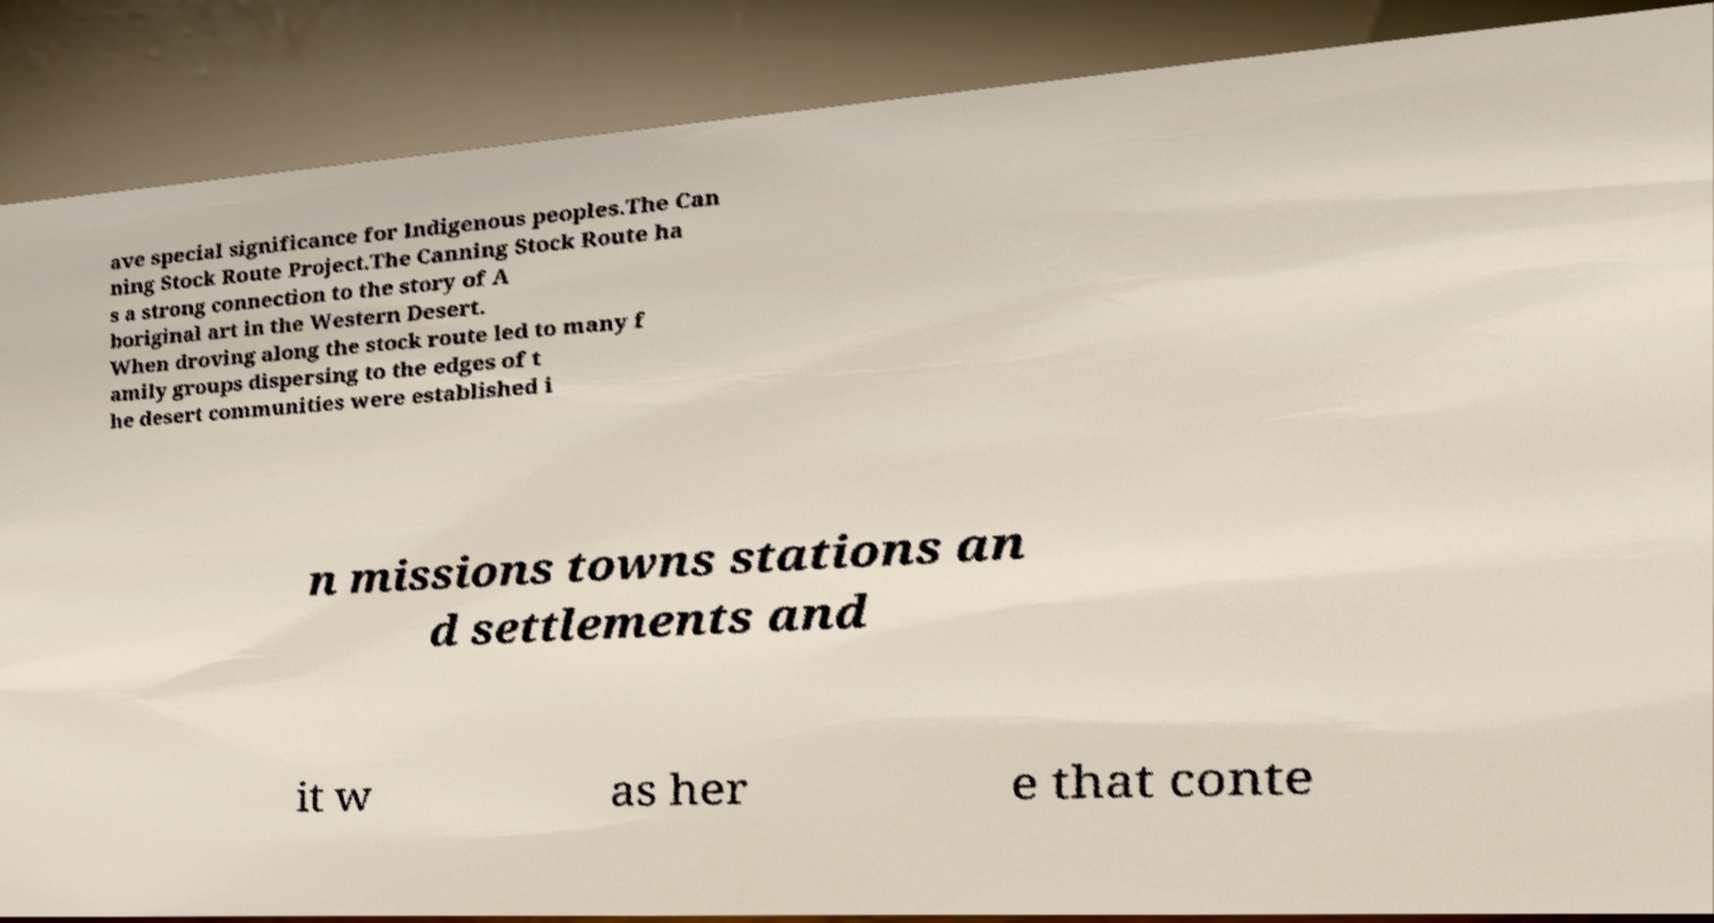Can you read and provide the text displayed in the image?This photo seems to have some interesting text. Can you extract and type it out for me? ave special significance for Indigenous peoples.The Can ning Stock Route Project.The Canning Stock Route ha s a strong connection to the story of A boriginal art in the Western Desert. When droving along the stock route led to many f amily groups dispersing to the edges of t he desert communities were established i n missions towns stations an d settlements and it w as her e that conte 